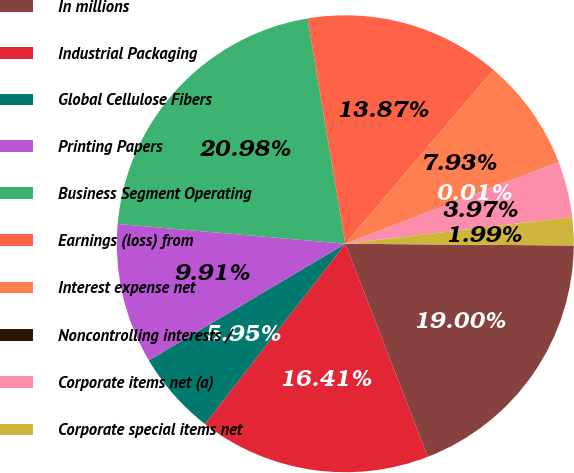Convert chart. <chart><loc_0><loc_0><loc_500><loc_500><pie_chart><fcel>In millions<fcel>Industrial Packaging<fcel>Global Cellulose Fibers<fcel>Printing Papers<fcel>Business Segment Operating<fcel>Earnings (loss) from<fcel>Interest expense net<fcel>Noncontrolling interests /<fcel>Corporate items net (a)<fcel>Corporate special items net<nl><fcel>19.0%<fcel>16.41%<fcel>5.95%<fcel>9.91%<fcel>20.98%<fcel>13.87%<fcel>7.93%<fcel>0.01%<fcel>3.97%<fcel>1.99%<nl></chart> 